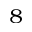Convert formula to latex. <formula><loc_0><loc_0><loc_500><loc_500>^ { 8 }</formula> 